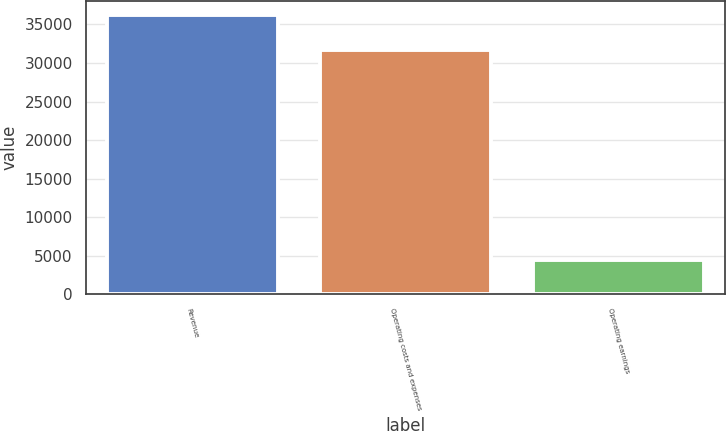Convert chart. <chart><loc_0><loc_0><loc_500><loc_500><bar_chart><fcel>Revenue<fcel>Operating costs and expenses<fcel>Operating earnings<nl><fcel>36193<fcel>31736<fcel>4457<nl></chart> 